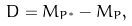Convert formula to latex. <formula><loc_0><loc_0><loc_500><loc_500>\ D = M _ { P ^ { \ast } } - M _ { P } ,</formula> 